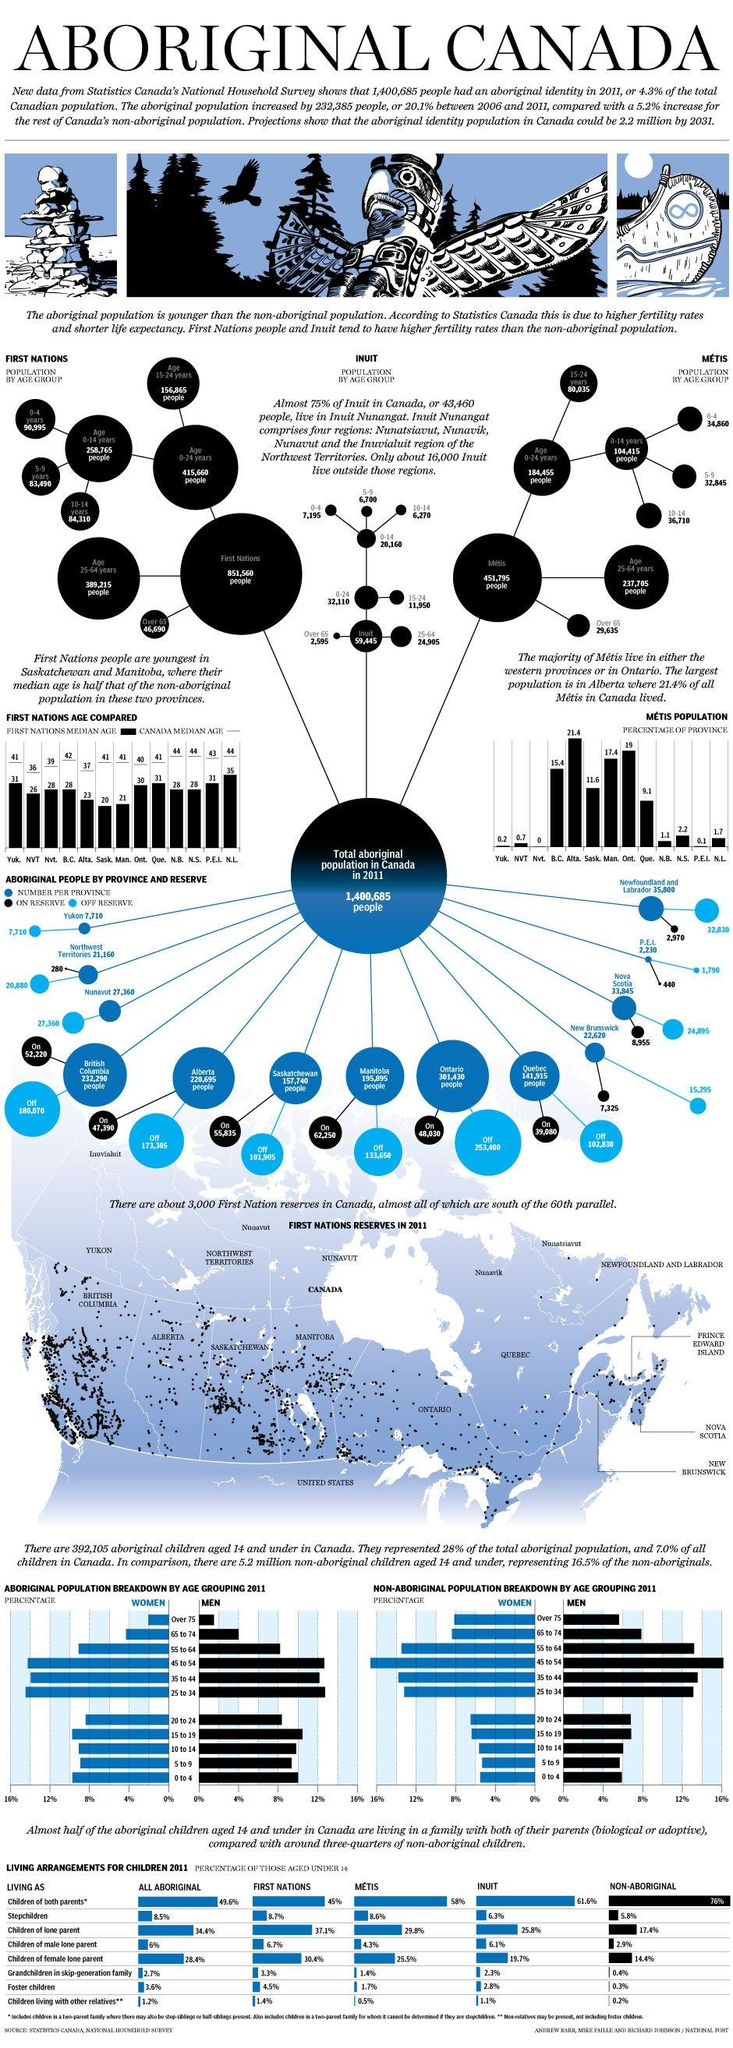Indicate a few pertinent items in this graphic. The median age of the First Nations population in Ontario in 2011 was 30 years old. According to the 2011 Canadian census, the Canadian province of Ontario has the highest aboriginal population. According to the data from 2011, British Columbia has the second-highest aboriginal population in Canada. In 2011, the number of Aboriginal people in Quebec was 141,915. The majority of the First Nations population in Canada in 2011 was under the age of 24, with the age range being 0-24 years. 